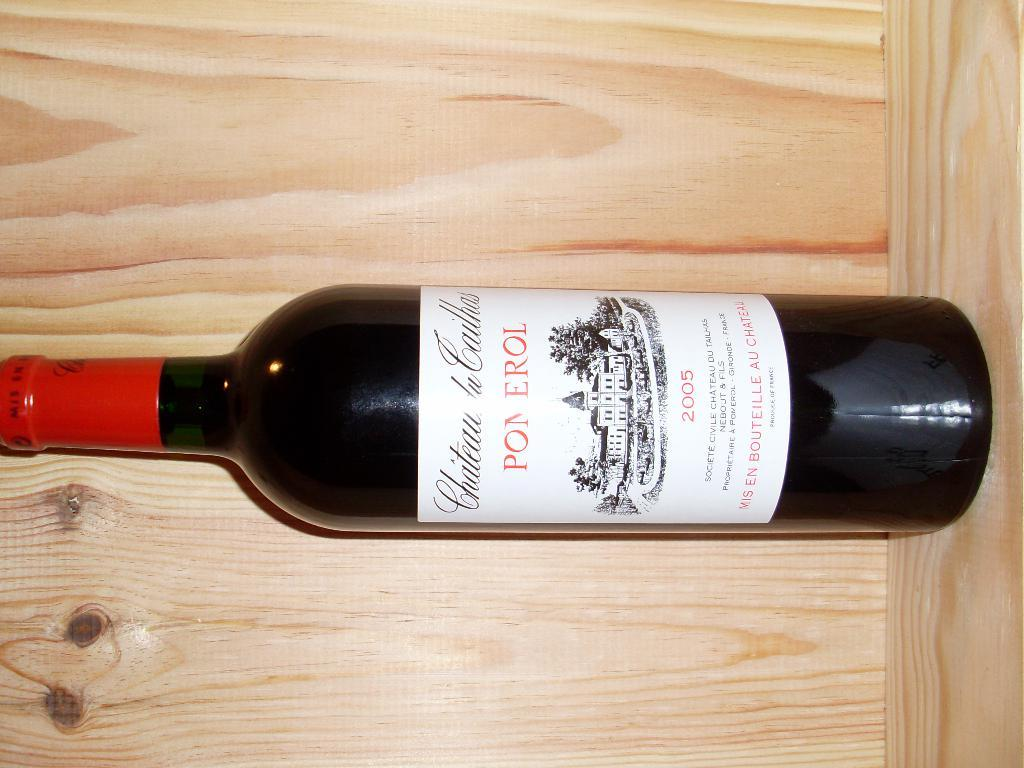<image>
Share a concise interpretation of the image provided. A dark colored bottle of Chateau de Cailhas Pomeral from 2005 with a white label and red foil capping. 